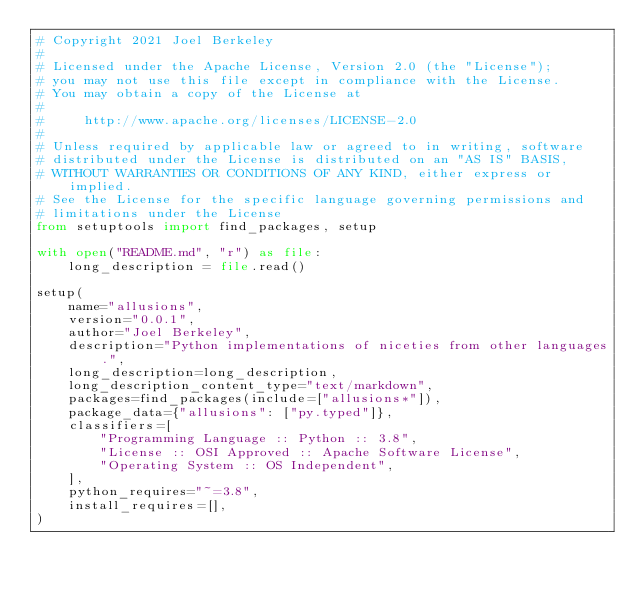Convert code to text. <code><loc_0><loc_0><loc_500><loc_500><_Python_># Copyright 2021 Joel Berkeley
#
# Licensed under the Apache License, Version 2.0 (the "License");
# you may not use this file except in compliance with the License.
# You may obtain a copy of the License at
#
#     http://www.apache.org/licenses/LICENSE-2.0
#
# Unless required by applicable law or agreed to in writing, software
# distributed under the License is distributed on an "AS IS" BASIS,
# WITHOUT WARRANTIES OR CONDITIONS OF ANY KIND, either express or implied.
# See the License for the specific language governing permissions and
# limitations under the License
from setuptools import find_packages, setup

with open("README.md", "r") as file:
    long_description = file.read()

setup(
    name="allusions",
    version="0.0.1",
    author="Joel Berkeley",
    description="Python implementations of niceties from other languages.",
    long_description=long_description,
    long_description_content_type="text/markdown",
    packages=find_packages(include=["allusions*"]),
    package_data={"allusions": ["py.typed"]},
    classifiers=[
        "Programming Language :: Python :: 3.8",
        "License :: OSI Approved :: Apache Software License",
        "Operating System :: OS Independent",
    ],
    python_requires="~=3.8",
    install_requires=[],
)
</code> 